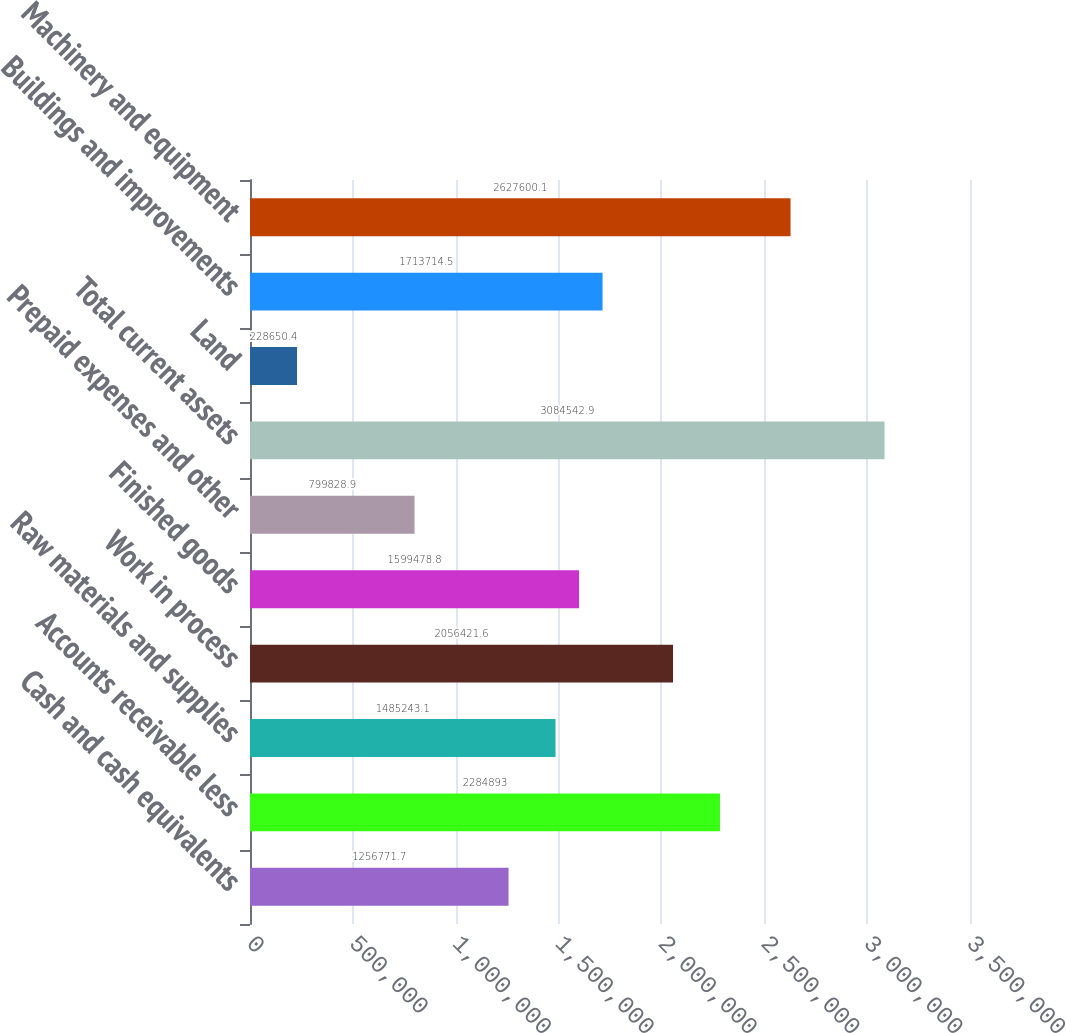Convert chart. <chart><loc_0><loc_0><loc_500><loc_500><bar_chart><fcel>Cash and cash equivalents<fcel>Accounts receivable less<fcel>Raw materials and supplies<fcel>Work in process<fcel>Finished goods<fcel>Prepaid expenses and other<fcel>Total current assets<fcel>Land<fcel>Buildings and improvements<fcel>Machinery and equipment<nl><fcel>1.25677e+06<fcel>2.28489e+06<fcel>1.48524e+06<fcel>2.05642e+06<fcel>1.59948e+06<fcel>799829<fcel>3.08454e+06<fcel>228650<fcel>1.71371e+06<fcel>2.6276e+06<nl></chart> 